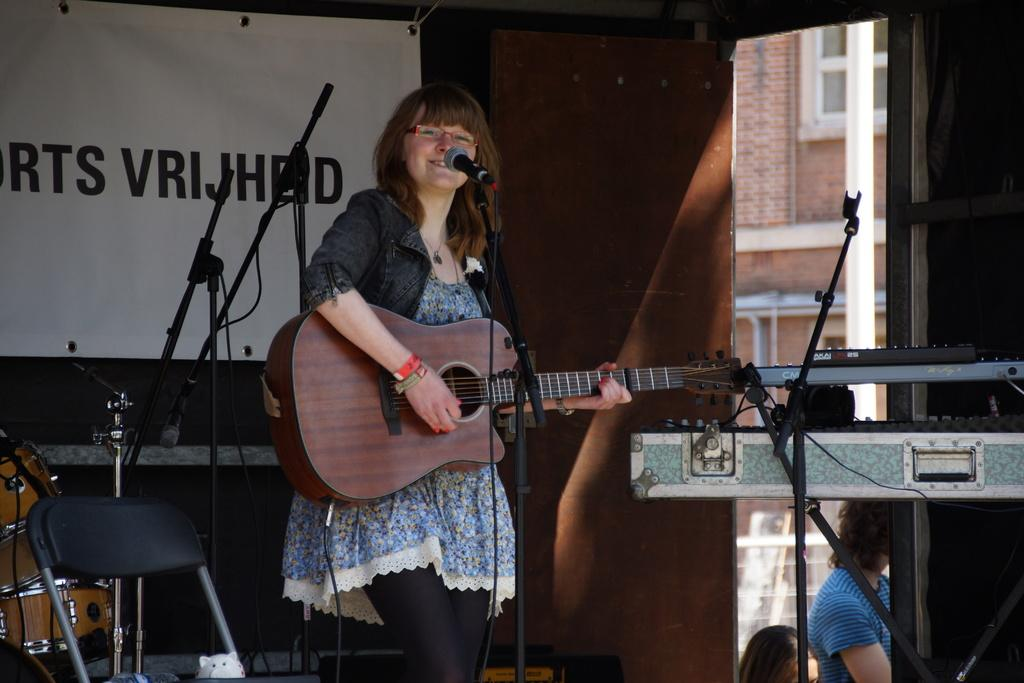Who is the main subject in the image? There is a lady in the image. What is the lady holding in the image? The lady is holding a guitar. What is the lady doing with the guitar? The lady is playing the guitar. What other musical instrument can be seen in the image? There is another musical instrument in the image. What object is typically used for amplifying sound in the image? There is a microphone in the image. What piece of furniture is present in the image? There is a chair in the image. What type of tree can be seen growing in the image? There is no tree present in the image. What is the lady using to store her guitar picks in the image? There is no jar or any object used for storing guitar picks visible in the image. 